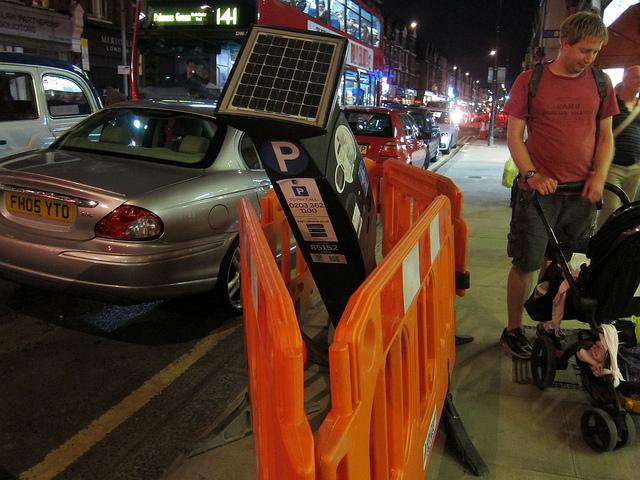Which make of vehicle is parked nearest to the meter? Please explain your reasoning. jaguar. The vehicle is a jaguar. 